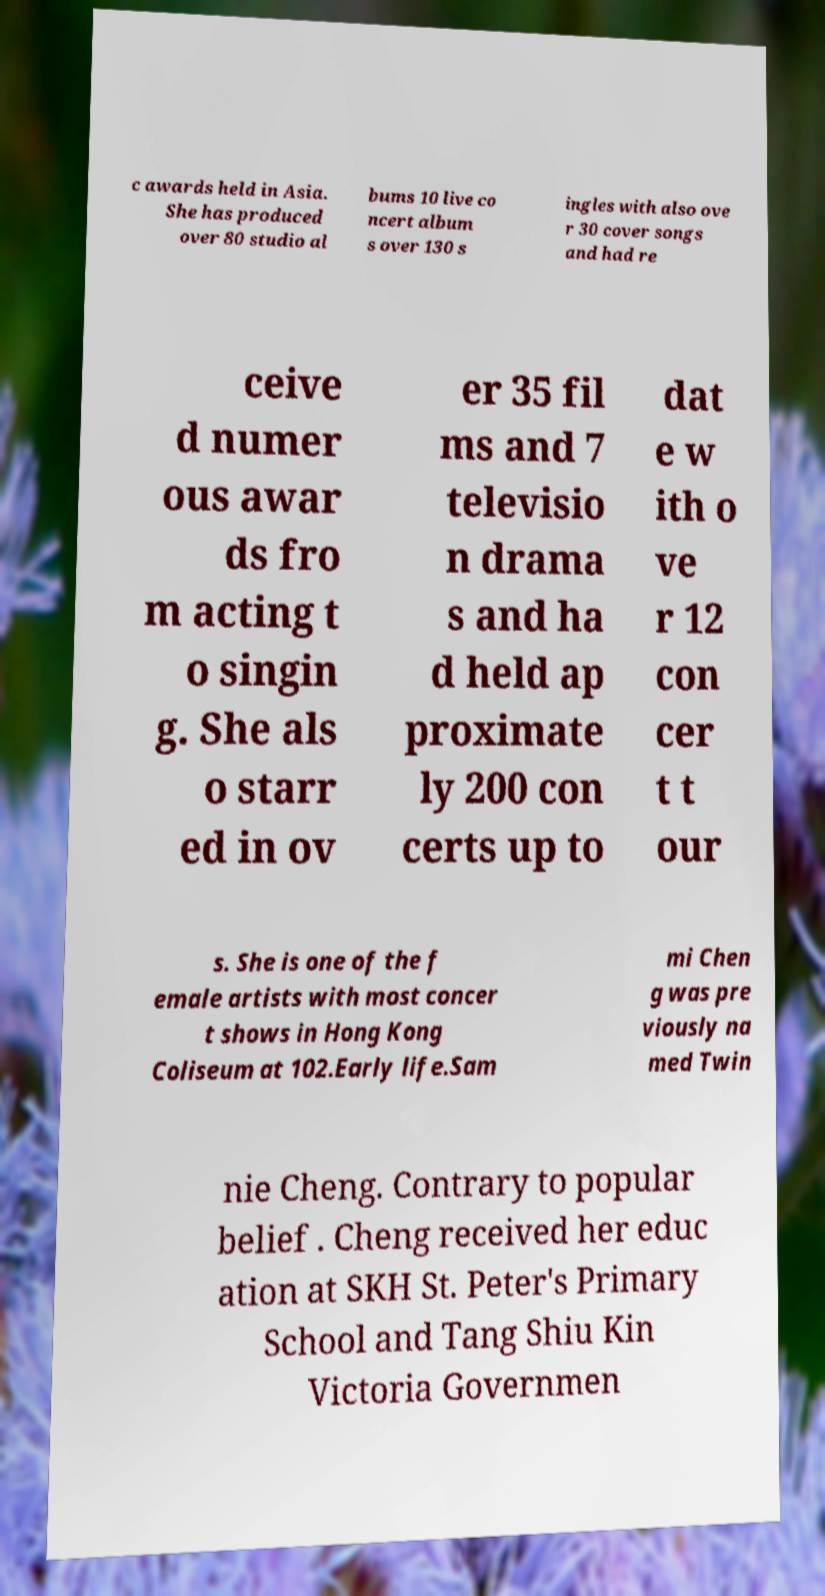Please read and relay the text visible in this image. What does it say? c awards held in Asia. She has produced over 80 studio al bums 10 live co ncert album s over 130 s ingles with also ove r 30 cover songs and had re ceive d numer ous awar ds fro m acting t o singin g. She als o starr ed in ov er 35 fil ms and 7 televisio n drama s and ha d held ap proximate ly 200 con certs up to dat e w ith o ve r 12 con cer t t our s. She is one of the f emale artists with most concer t shows in Hong Kong Coliseum at 102.Early life.Sam mi Chen g was pre viously na med Twin nie Cheng. Contrary to popular belief . Cheng received her educ ation at SKH St. Peter's Primary School and Tang Shiu Kin Victoria Governmen 